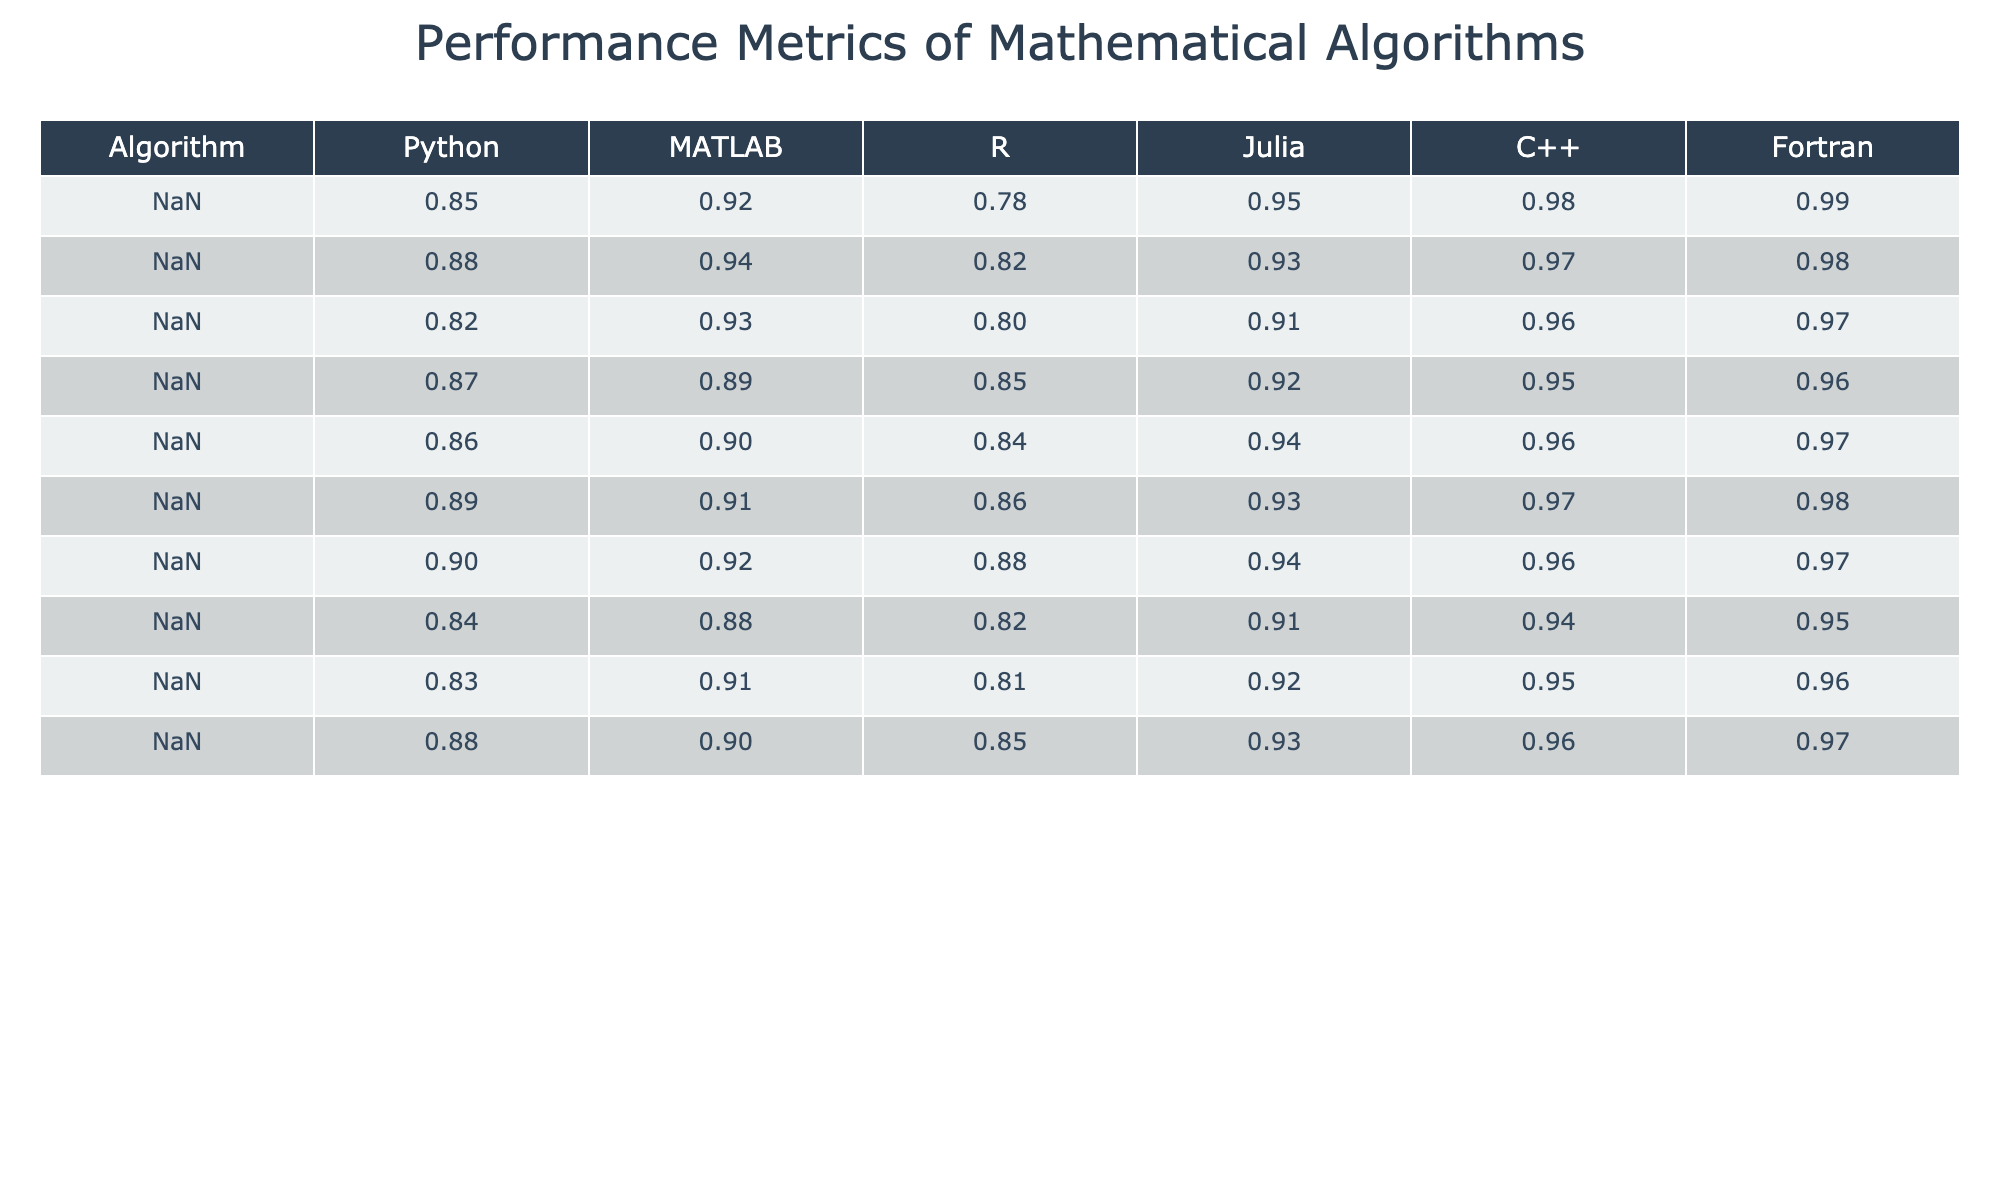What is the performance metric for Matrix Multiplication in Python? The table shows the performance metric for Matrix Multiplication in Python is 0.85.
Answer: 0.85 Which programming environment has the highest metric for Fast Fourier Transform? The table indicates that C++ has the highest performance metric for Fast Fourier Transform at 0.97.
Answer: C++ What is the difference in performance metrics between K-Means Clustering in Fortran and Python? The performance metric for K-Means Clustering in Fortran is 0.95 and in Python is 0.84. The difference is 0.95 - 0.84 = 0.11.
Answer: 0.11 Is the performance metric for Gradient Descent in R greater than 0.85? The performance metric for Gradient Descent in R is 0.85, which is not greater than 0.85, so the answer is false.
Answer: False What is the average performance metric for Numerical Integration across all programming environments? The metrics for Numerical Integration are 0.89 (Python), 0.91 (MATLAB), 0.86 (R), 0.93 (Julia), 0.97 (C++), and 0.98 (Fortran). The sum of these values is 0.89 + 0.91 + 0.86 + 0.93 + 0.97 + 0.98 = 5.54. Dividing by 6 gives an average of 5.54 / 6 = 0.9233.
Answer: 0.9233 Which algorithm has the lowest performance metric in R? The table shows that K-Means Clustering has the lowest performance metric in R at 0.82.
Answer: K-Means Clustering What is the performance metric for Singular Value Decomposition in Julia relative to C++? The performance metric for Singular Value Decomposition in Julia is 0.91 and for C++ is 0.96. The relative value is 0.91 < 0.96, indicating Julia performs worse than C++.
Answer: Julia performs worse Are there any algorithms where the performance in Fortran is less than that in MATLAB? By reviewing the table, all performance metrics in Fortran are equal to or greater than those in MATLAB. Therefore, the answer is no.
Answer: No If we consider the top two programming environments for each algorithm, which environment has the overall highest performance for Matrix Multiplication? C++ (0.98) and Fortran (0.99) are the top two metrics for Matrix Multiplication. Among programming environments, Fortran has the highest metric across algorithms, including Matrix Multiplication.
Answer: Fortran What is the cumulative performance metric for Monte Carlo Simulation across all programming environments? The metrics for Monte Carlo Simulation are 0.86 (Python), 0.90 (MATLAB), 0.84 (R), 0.94 (Julia), 0.96 (C++), and 0.97 (Fortran). Adding these together gives 0.86 + 0.90 + 0.84 + 0.94 + 0.96 + 0.97 = 5.47.
Answer: 5.47 